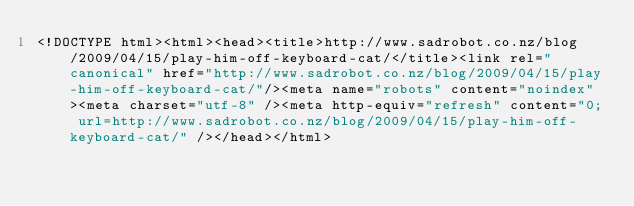Convert code to text. <code><loc_0><loc_0><loc_500><loc_500><_HTML_><!DOCTYPE html><html><head><title>http://www.sadrobot.co.nz/blog/2009/04/15/play-him-off-keyboard-cat/</title><link rel="canonical" href="http://www.sadrobot.co.nz/blog/2009/04/15/play-him-off-keyboard-cat/"/><meta name="robots" content="noindex"><meta charset="utf-8" /><meta http-equiv="refresh" content="0; url=http://www.sadrobot.co.nz/blog/2009/04/15/play-him-off-keyboard-cat/" /></head></html></code> 